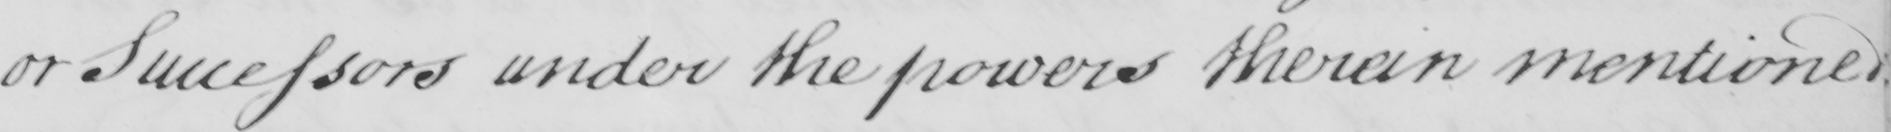What does this handwritten line say? or Successors under the powers therein mentioned 